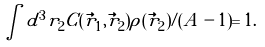<formula> <loc_0><loc_0><loc_500><loc_500>\int d ^ { 3 } r _ { 2 } C ( \vec { r } _ { 1 } , \vec { r } _ { 2 } ) \rho ( \vec { r } _ { 2 } ) / ( A - 1 ) = 1 .</formula> 